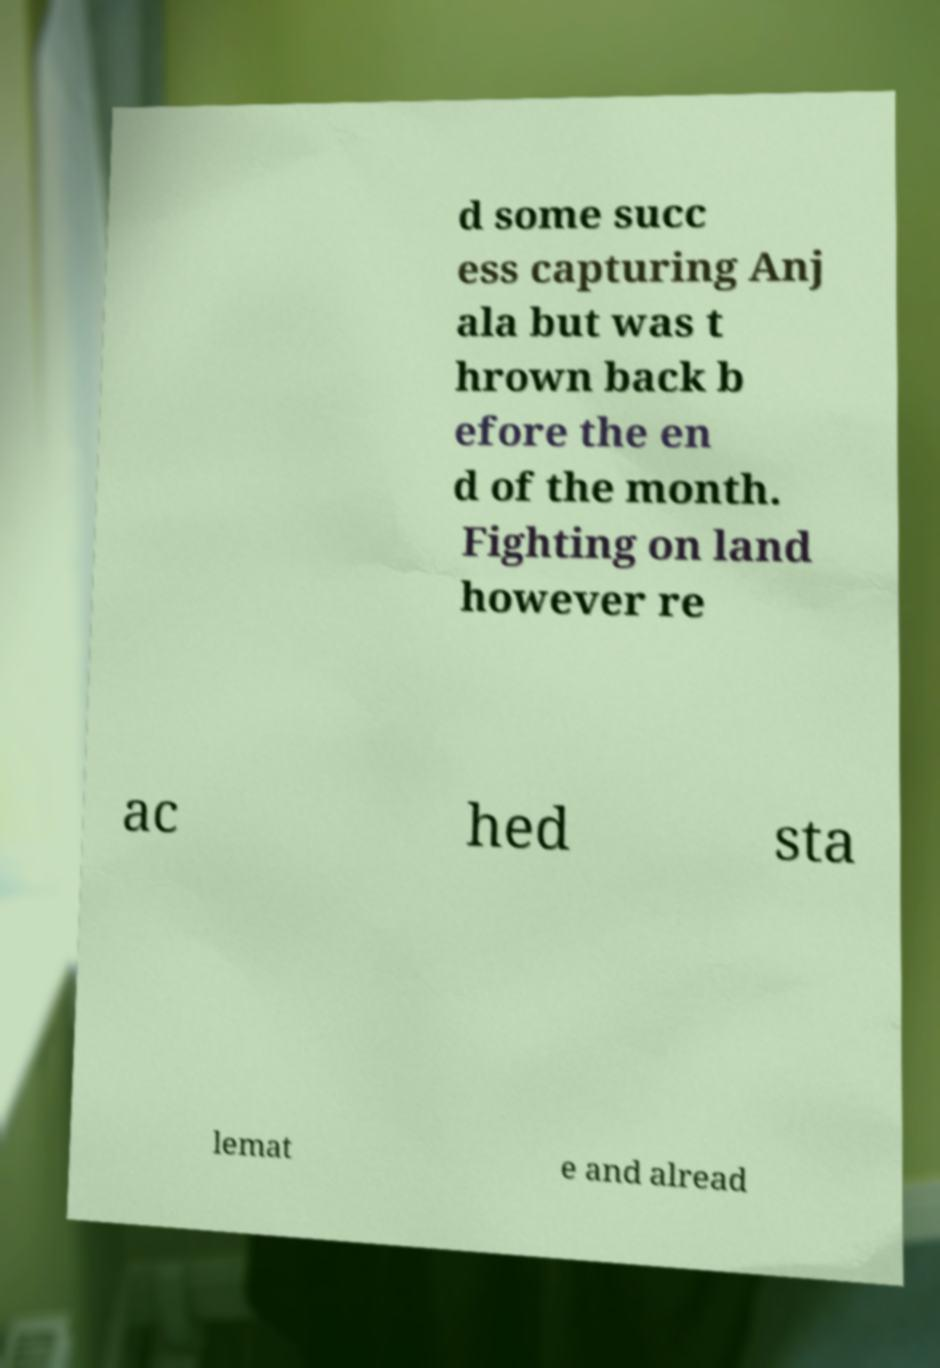For documentation purposes, I need the text within this image transcribed. Could you provide that? d some succ ess capturing Anj ala but was t hrown back b efore the en d of the month. Fighting on land however re ac hed sta lemat e and alread 